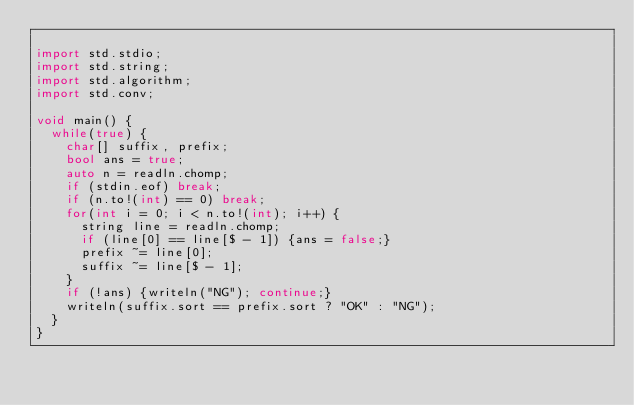Convert code to text. <code><loc_0><loc_0><loc_500><loc_500><_D_>
import std.stdio;
import std.string;
import std.algorithm;
import std.conv;

void main() {
  while(true) {
    char[] suffix, prefix;
    bool ans = true;
    auto n = readln.chomp;
    if (stdin.eof) break;
    if (n.to!(int) == 0) break;
    for(int i = 0; i < n.to!(int); i++) {
      string line = readln.chomp;
      if (line[0] == line[$ - 1]) {ans = false;}
      prefix ~= line[0];
      suffix ~= line[$ - 1];
    }
    if (!ans) {writeln("NG"); continue;}
    writeln(suffix.sort == prefix.sort ? "OK" : "NG");
  }
}</code> 